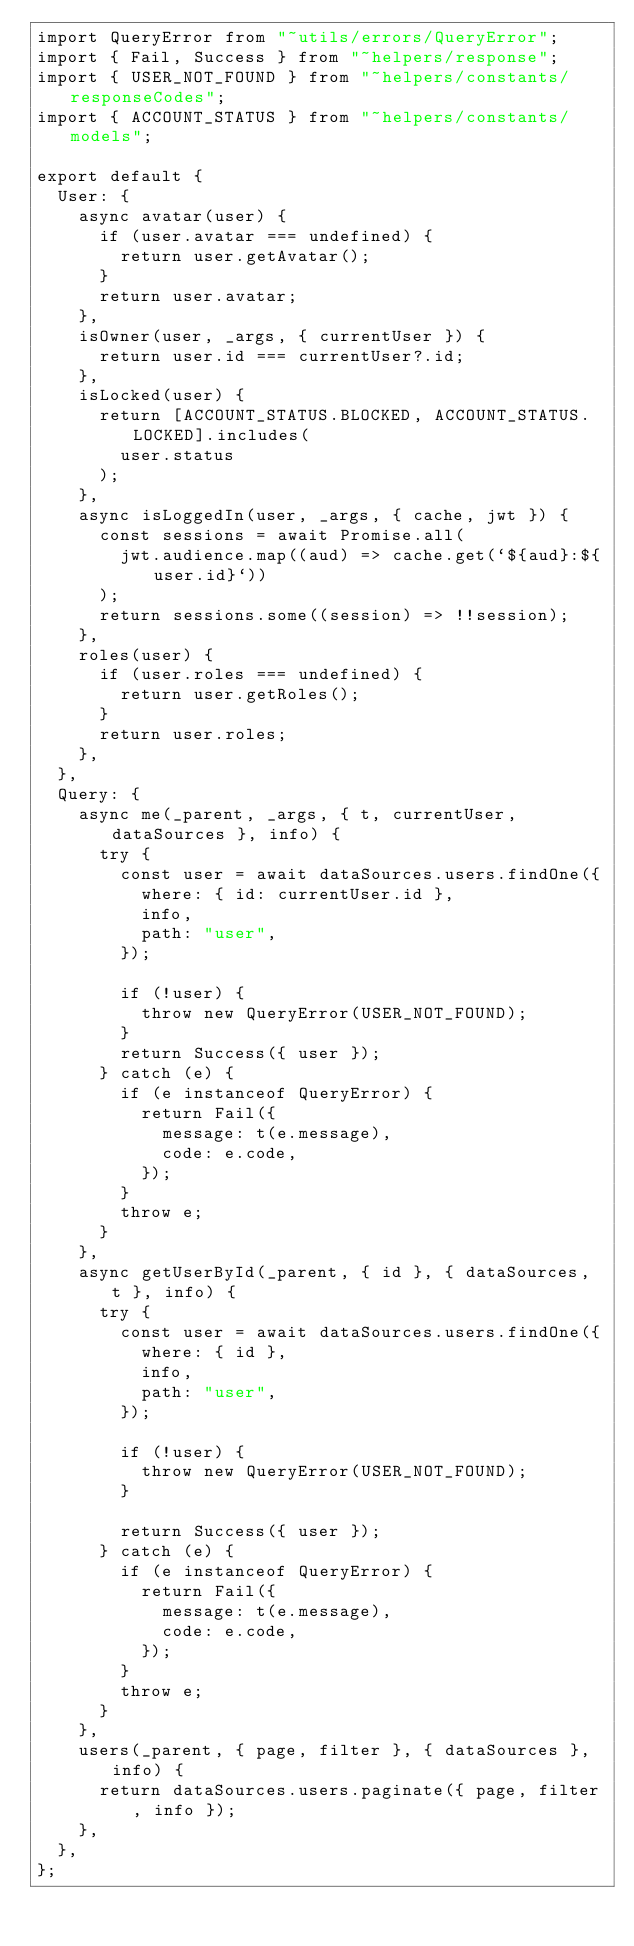Convert code to text. <code><loc_0><loc_0><loc_500><loc_500><_JavaScript_>import QueryError from "~utils/errors/QueryError";
import { Fail, Success } from "~helpers/response";
import { USER_NOT_FOUND } from "~helpers/constants/responseCodes";
import { ACCOUNT_STATUS } from "~helpers/constants/models";

export default {
  User: {
    async avatar(user) {
      if (user.avatar === undefined) {
        return user.getAvatar();
      }
      return user.avatar;
    },
    isOwner(user, _args, { currentUser }) {
      return user.id === currentUser?.id;
    },
    isLocked(user) {
      return [ACCOUNT_STATUS.BLOCKED, ACCOUNT_STATUS.LOCKED].includes(
        user.status
      );
    },
    async isLoggedIn(user, _args, { cache, jwt }) {
      const sessions = await Promise.all(
        jwt.audience.map((aud) => cache.get(`${aud}:${user.id}`))
      );
      return sessions.some((session) => !!session);
    },
    roles(user) {
      if (user.roles === undefined) {
        return user.getRoles();
      }
      return user.roles;
    },
  },
  Query: {
    async me(_parent, _args, { t, currentUser, dataSources }, info) {
      try {
        const user = await dataSources.users.findOne({
          where: { id: currentUser.id },
          info,
          path: "user",
        });

        if (!user) {
          throw new QueryError(USER_NOT_FOUND);
        }
        return Success({ user });
      } catch (e) {
        if (e instanceof QueryError) {
          return Fail({
            message: t(e.message),
            code: e.code,
          });
        }
        throw e;
      }
    },
    async getUserById(_parent, { id }, { dataSources, t }, info) {
      try {
        const user = await dataSources.users.findOne({
          where: { id },
          info,
          path: "user",
        });

        if (!user) {
          throw new QueryError(USER_NOT_FOUND);
        }

        return Success({ user });
      } catch (e) {
        if (e instanceof QueryError) {
          return Fail({
            message: t(e.message),
            code: e.code,
          });
        }
        throw e;
      }
    },
    users(_parent, { page, filter }, { dataSources }, info) {
      return dataSources.users.paginate({ page, filter, info });
    },
  },
};
</code> 